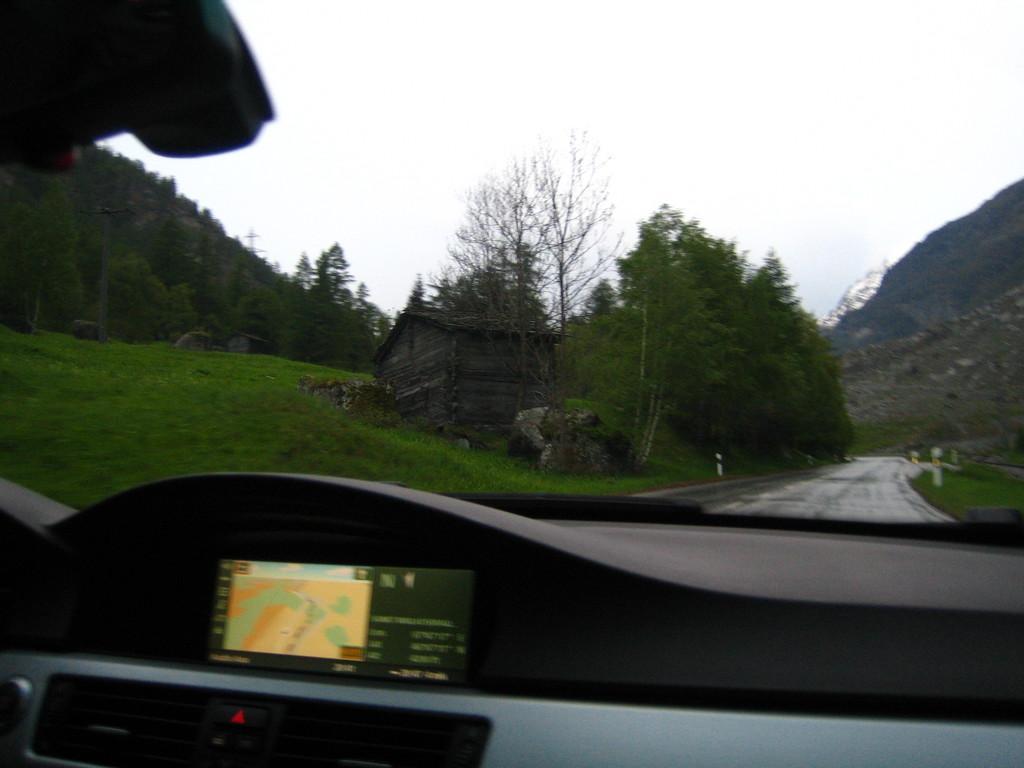Can you describe this image briefly? In this picture there is a car and at left and right side of the image there is grass on the surface and at the back side there are trees and on left side of the image there is hut and at the background there is sky. 